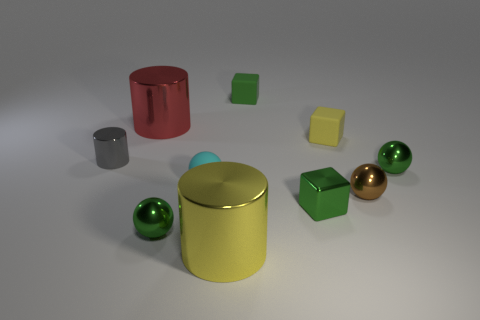Subtract all cylinders. How many objects are left? 7 Subtract 0 purple blocks. How many objects are left? 10 Subtract all small yellow blocks. Subtract all tiny brown matte cubes. How many objects are left? 9 Add 9 brown balls. How many brown balls are left? 10 Add 1 small cyan spheres. How many small cyan spheres exist? 2 